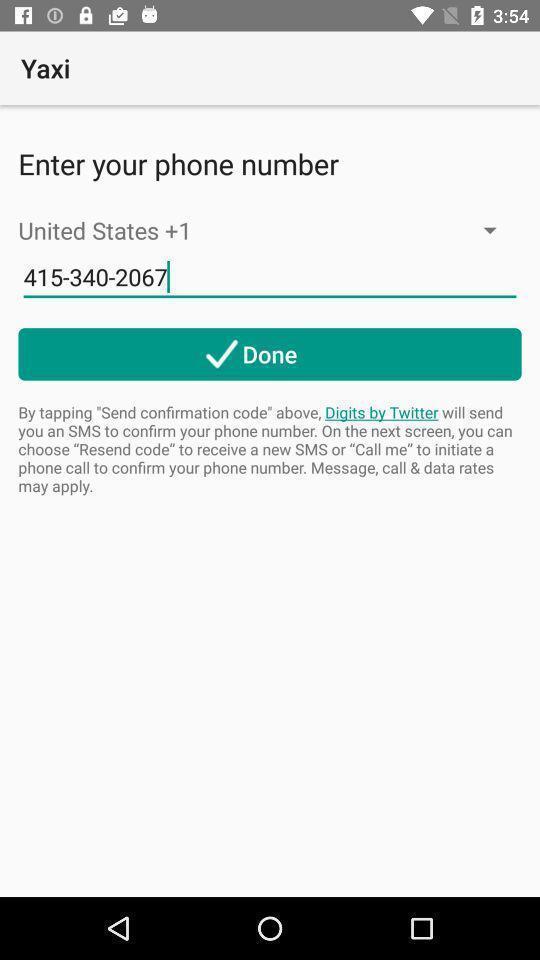What can you discern from this picture? Page for entering phone number. 